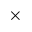<formula> <loc_0><loc_0><loc_500><loc_500>\times</formula> 